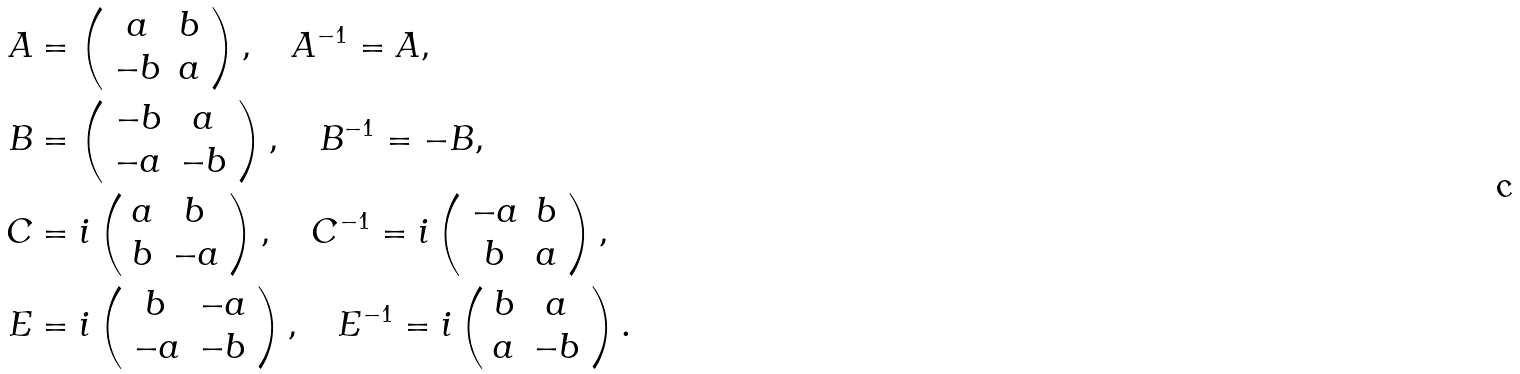Convert formula to latex. <formula><loc_0><loc_0><loc_500><loc_500>A & = \left ( \begin{array} { c c } a & b \\ - b & a \end{array} \right ) , \quad A ^ { - 1 } = A , \\ B & = \left ( \begin{array} { c c } - b & a \\ - a & - b \end{array} \right ) , \quad B ^ { - 1 } = - B , \\ C & = i \left ( \begin{array} { c c } a & b \\ b & - a \end{array} \right ) , \quad C ^ { - 1 } = i \left ( \begin{array} { c c } - a & b \\ b & a \end{array} \right ) , \\ E & = i \left ( \begin{array} { c c } b & - a \\ - a & - b \end{array} \right ) , \quad E ^ { - 1 } = i \left ( \begin{array} { c c } b & a \\ a & - b \end{array} \right ) . \\</formula> 